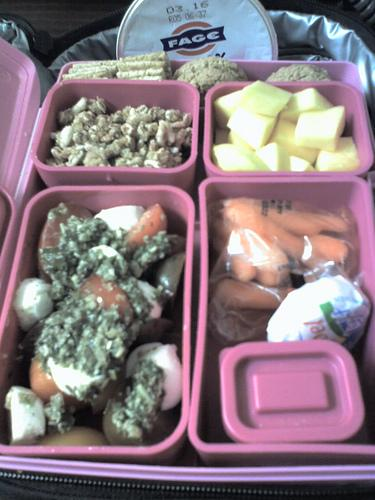What does the company whose logo appears at the top specialize in? Please explain your reasoning. yogurt. The object in question is consistent with answer a. the brand is also readable and can be internet searched if not commonly known. 